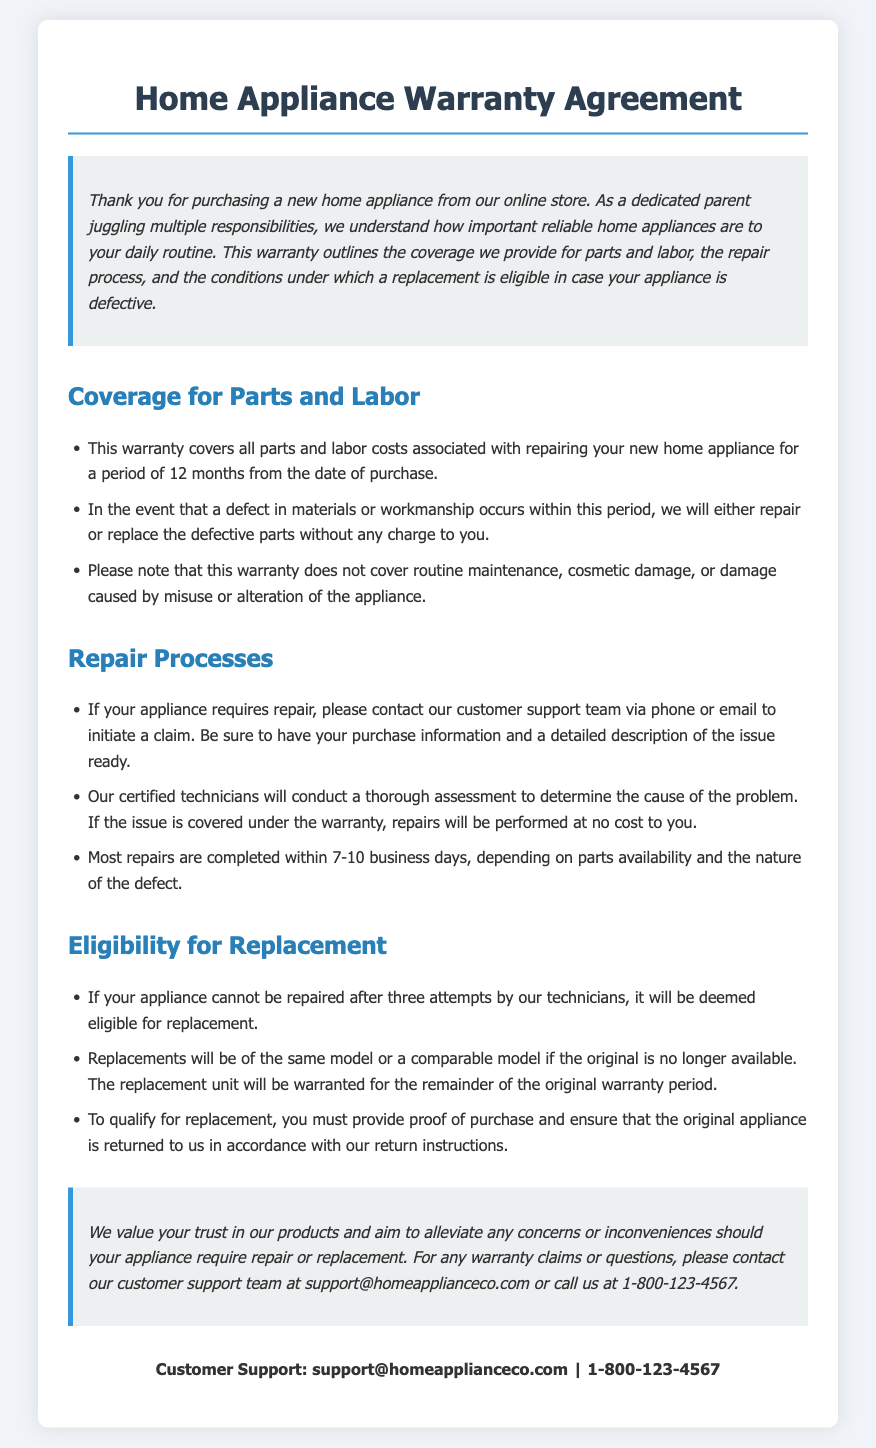what is the warranty period for the appliance? The warranty covers repairs for a period of 12 months from the date of purchase.
Answer: 12 months what must you have ready when contacting customer support? You need to have your purchase information and a detailed description of the issue.
Answer: Purchase information and description of the issue how long do most repairs take? The document states repairs are completed within 7-10 business days.
Answer: 7-10 business days what happens after three repair attempts? If the appliance cannot be repaired after three attempts, it is eligible for replacement.
Answer: Eligible for replacement what type of damage is not covered by the warranty? The warranty does not cover routine maintenance or cosmetic damage.
Answer: Routine maintenance and cosmetic damage what is required to qualify for a replacement? You must provide proof of purchase and return the original appliance.
Answer: Proof of purchase and return of original appliance how are replacements handled if the original model is unavailable? Replacements will be of the same model or a comparable model if the original is unavailable.
Answer: Same or comparable model what are the contact methods for warranty claims? You can contact customer support via phone or email.
Answer: Phone or email how will the replacement unit be warranted? The replacement unit will be warranted for the remainder of the original warranty period.
Answer: Remainder of the original warranty period 